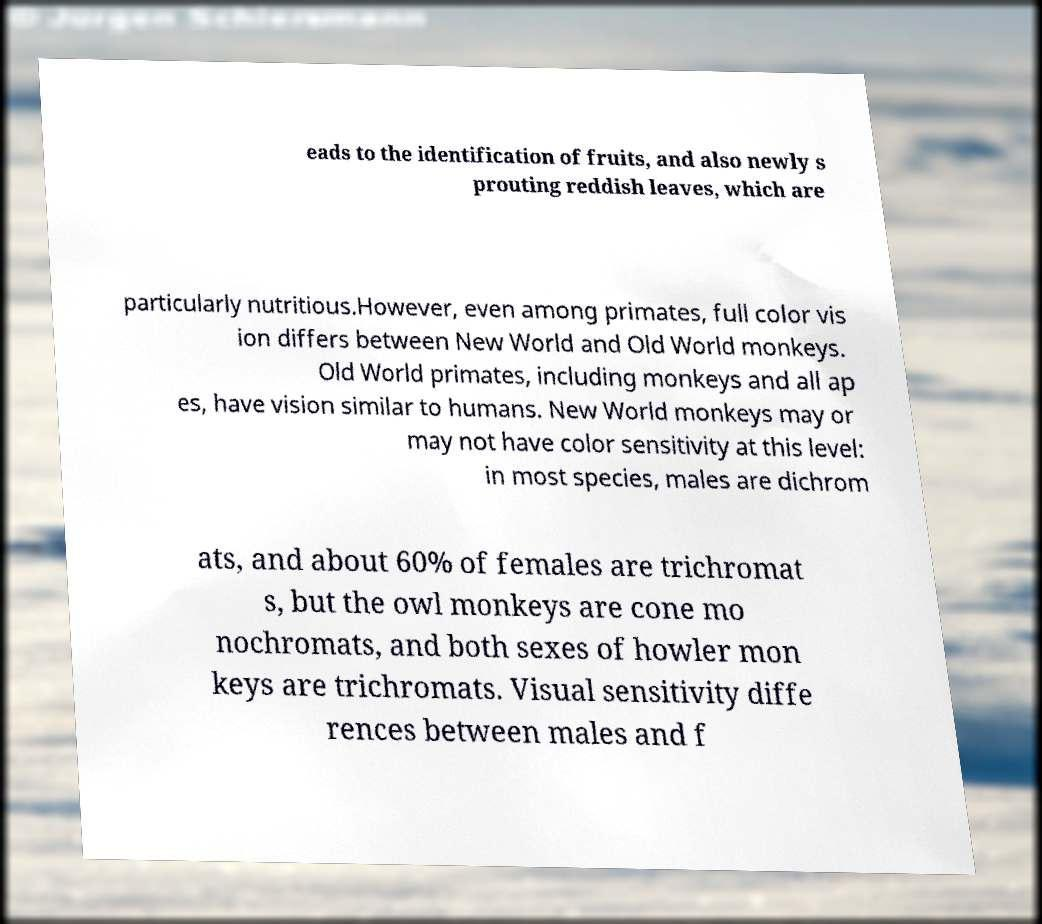Please read and relay the text visible in this image. What does it say? eads to the identification of fruits, and also newly s prouting reddish leaves, which are particularly nutritious.However, even among primates, full color vis ion differs between New World and Old World monkeys. Old World primates, including monkeys and all ap es, have vision similar to humans. New World monkeys may or may not have color sensitivity at this level: in most species, males are dichrom ats, and about 60% of females are trichromat s, but the owl monkeys are cone mo nochromats, and both sexes of howler mon keys are trichromats. Visual sensitivity diffe rences between males and f 